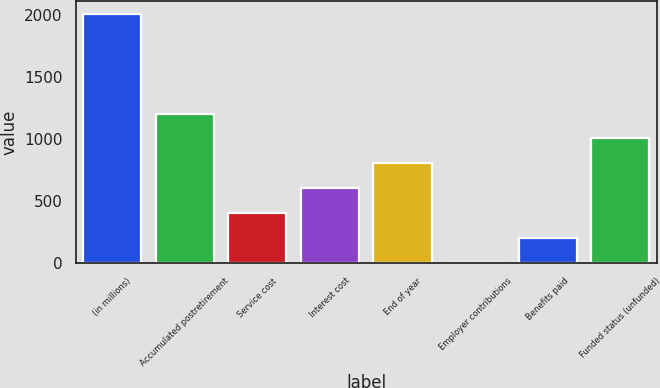Convert chart to OTSL. <chart><loc_0><loc_0><loc_500><loc_500><bar_chart><fcel>(in millions)<fcel>Accumulated postretirement<fcel>Service cost<fcel>Interest cost<fcel>End of year<fcel>Employer contributions<fcel>Benefits paid<fcel>Funded status (unfunded)<nl><fcel>2012<fcel>1208<fcel>404<fcel>605<fcel>806<fcel>2<fcel>203<fcel>1007<nl></chart> 